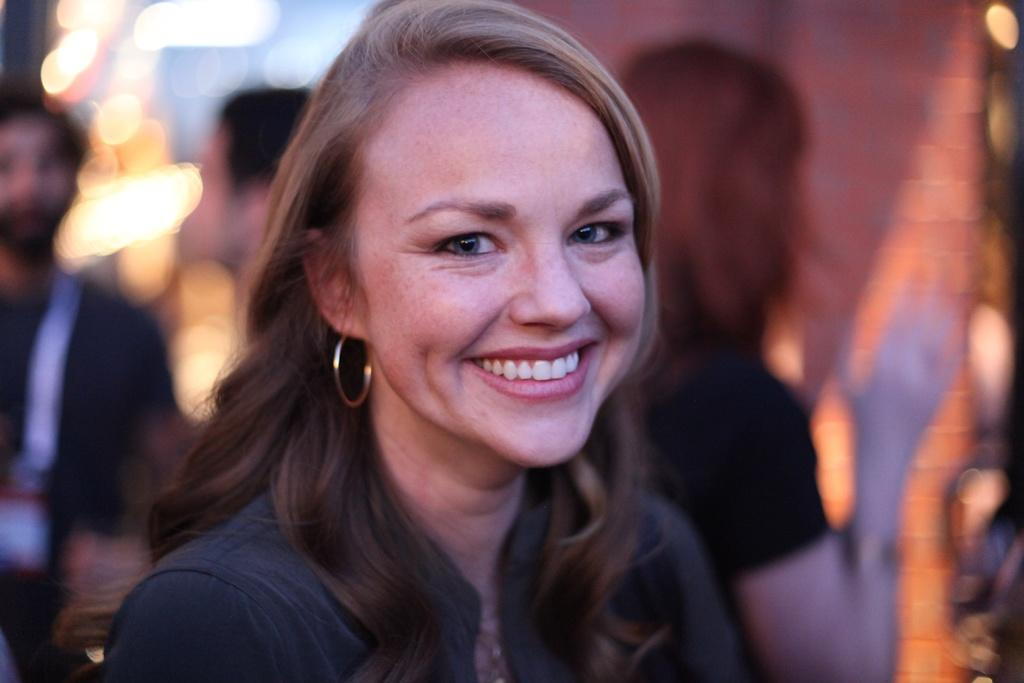What is the main subject of the image? The main subject of the image is a group of people. Can you describe the woman in the image? There is a woman in the middle of the image, and she is smiling. What can be seen in the background of the image? There are lights visible in the background of the image. How much money is being exchanged between the people in the image? There is no indication of money being exchanged in the image. What type of war is depicted in the image? There is no war depicted in the image; it features a group of people with a smiling woman in the middle. 